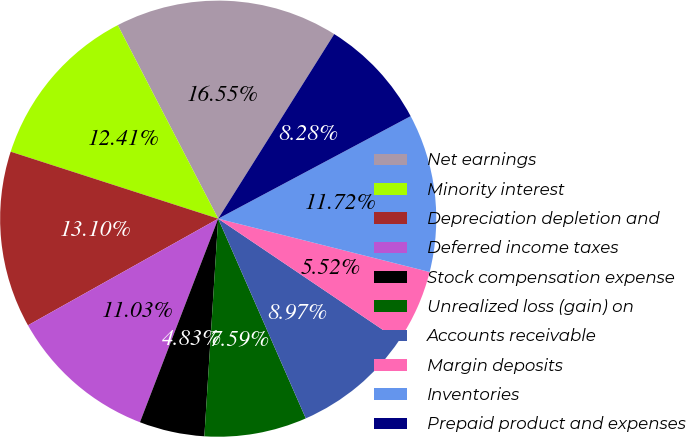Convert chart. <chart><loc_0><loc_0><loc_500><loc_500><pie_chart><fcel>Net earnings<fcel>Minority interest<fcel>Depreciation depletion and<fcel>Deferred income taxes<fcel>Stock compensation expense<fcel>Unrealized loss (gain) on<fcel>Accounts receivable<fcel>Margin deposits<fcel>Inventories<fcel>Prepaid product and expenses<nl><fcel>16.55%<fcel>12.41%<fcel>13.1%<fcel>11.03%<fcel>4.83%<fcel>7.59%<fcel>8.97%<fcel>5.52%<fcel>11.72%<fcel>8.28%<nl></chart> 